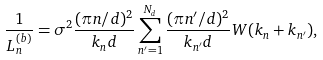<formula> <loc_0><loc_0><loc_500><loc_500>\frac { 1 } { L _ { n } ^ { ( b ) } } = \sigma ^ { 2 } \frac { ( \pi n / d ) ^ { 2 } } { k _ { n } d } \sum _ { n ^ { \prime } = 1 } ^ { N _ { d } } \frac { ( \pi n ^ { \prime } / d ) ^ { 2 } } { k _ { n ^ { \prime } } d } W ( k _ { n } + k _ { n ^ { \prime } } ) ,</formula> 